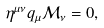<formula> <loc_0><loc_0><loc_500><loc_500>\eta ^ { \mu \nu } q _ { \mu } \mathcal { M } _ { \nu } = 0 ,</formula> 